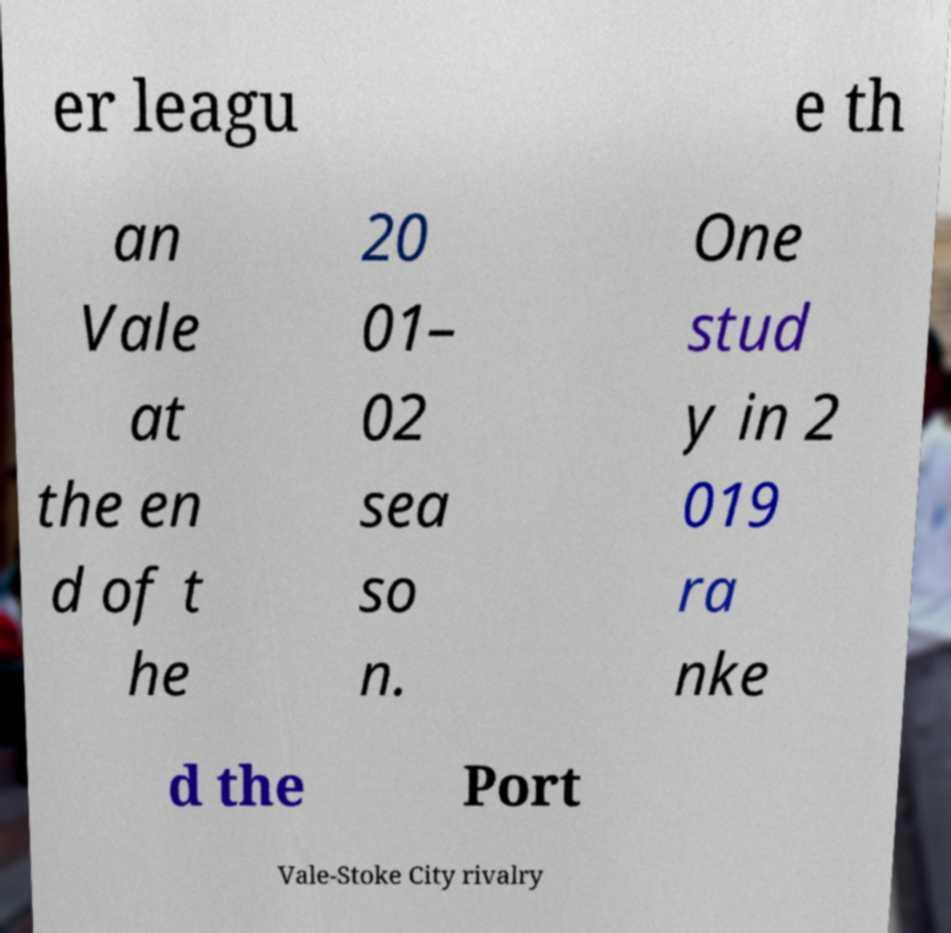Please identify and transcribe the text found in this image. er leagu e th an Vale at the en d of t he 20 01– 02 sea so n. One stud y in 2 019 ra nke d the Port Vale-Stoke City rivalry 